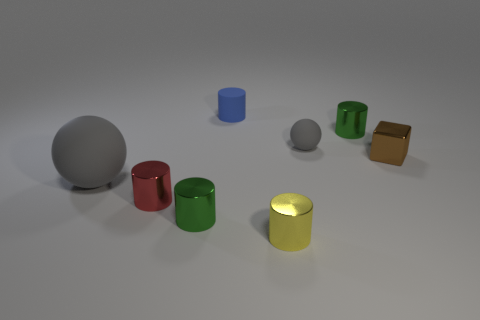Subtract all red cylinders. How many cylinders are left? 4 Add 1 large brown rubber cylinders. How many objects exist? 9 Subtract all green cylinders. How many cylinders are left? 3 Subtract all blocks. How many objects are left? 7 Subtract 1 balls. How many balls are left? 1 Subtract all red spheres. Subtract all brown cylinders. How many spheres are left? 2 Subtract all cyan blocks. How many blue cylinders are left? 1 Subtract all tiny yellow balls. Subtract all tiny yellow objects. How many objects are left? 7 Add 5 small rubber cylinders. How many small rubber cylinders are left? 6 Add 5 tiny shiny cylinders. How many tiny shiny cylinders exist? 9 